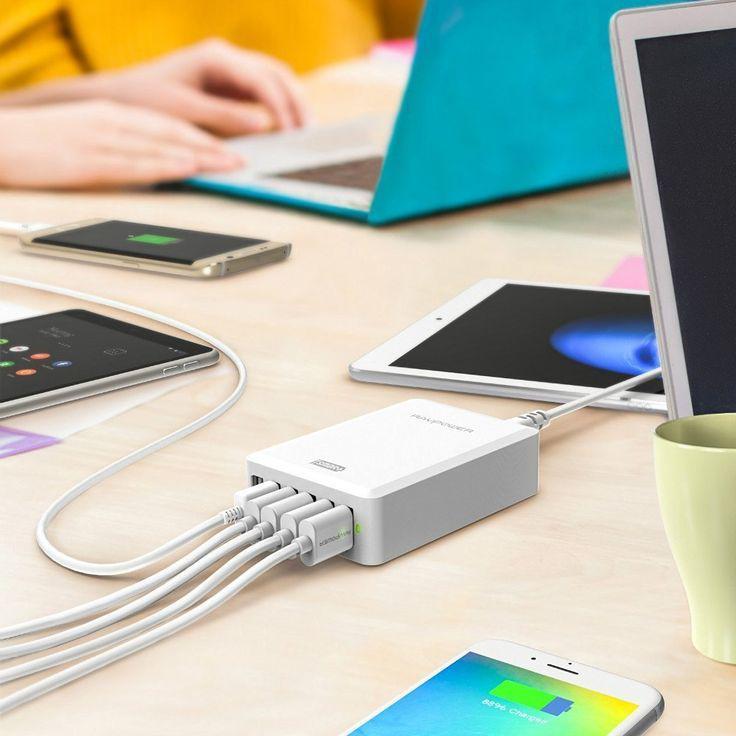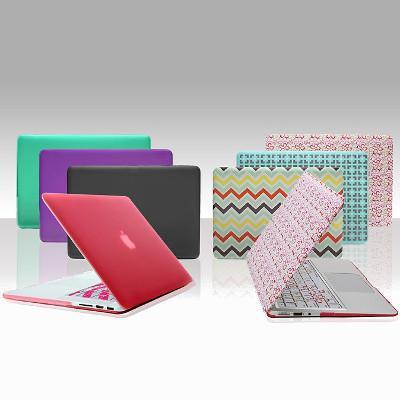The first image is the image on the left, the second image is the image on the right. Assess this claim about the two images: "A person's hand is near a digital device.". Correct or not? Answer yes or no. Yes. The first image is the image on the left, the second image is the image on the right. Analyze the images presented: Is the assertion "An image shows an open red device and a device with a patterned cover posed back-to-back in front of rows of closed devices." valid? Answer yes or no. Yes. 